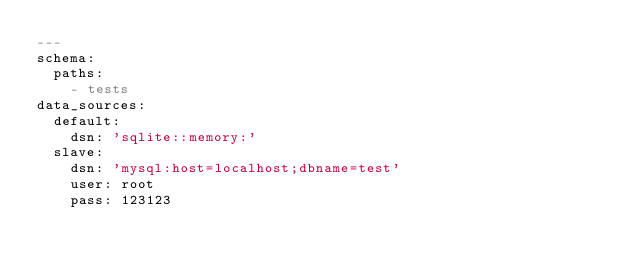Convert code to text. <code><loc_0><loc_0><loc_500><loc_500><_YAML_>---
schema:
  paths:
    - tests
data_sources:
  default:
    dsn: 'sqlite::memory:'
  slave:
    dsn: 'mysql:host=localhost;dbname=test'
    user: root
    pass: 123123
</code> 